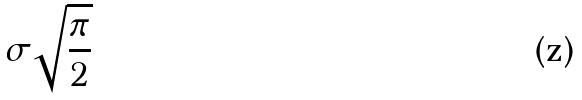Convert formula to latex. <formula><loc_0><loc_0><loc_500><loc_500>\sigma \sqrt { \frac { \pi } { 2 } }</formula> 